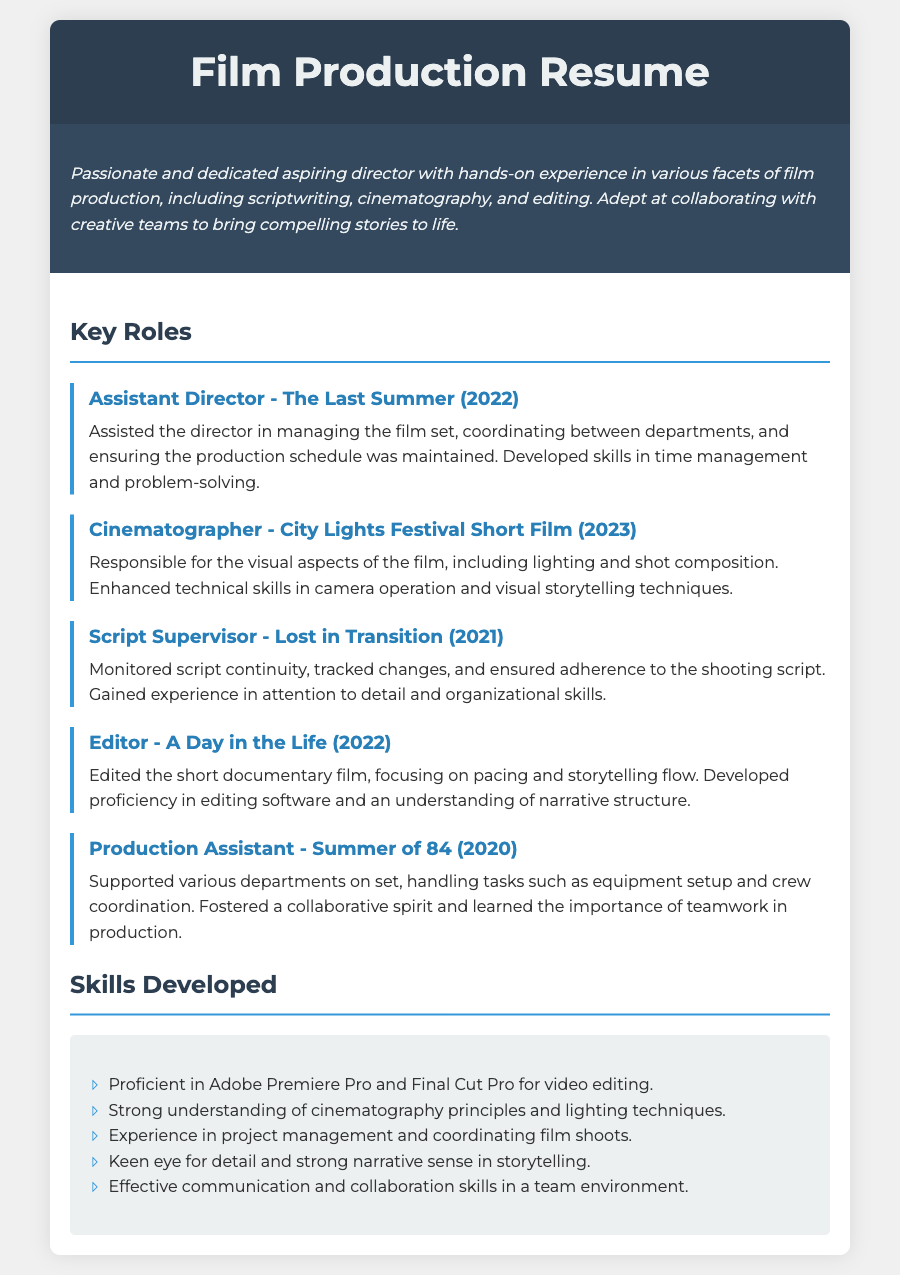what is the title of the resume? The title of the resume is indicated at the top of the document in a large font.
Answer: Film Production Resume who was the Assistant Director for The Last Summer? The name of the role and project are given in the section about key roles in the document.
Answer: Assistant Director in which year was City Lights Festival Short Film produced? The year of the project is specified alongside the role in the key roles section.
Answer: 2023 which skill involves using Adobe Premiere Pro? The skills listed include specific software proficiency relevant to the role.
Answer: video editing what role involves monitoring script continuity? The role tasked with this responsibility is described in the document.
Answer: Script Supervisor how many key roles are listed in total? The number of roles can be counted in the key roles section of the document.
Answer: Five which project did the individual work on as an Editor? The project title associated with the editing role is provided in the key roles section.
Answer: A Day in the Life what is a key skill in teamwork mentioned in the resume? The document emphasizes collaboration as a critical skill in film production.
Answer: teamwork which year was the Production Assistant role held? The role has a specific year mentioned in the key roles section of the resume.
Answer: 2020 